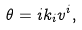Convert formula to latex. <formula><loc_0><loc_0><loc_500><loc_500>\theta = i k _ { i } v ^ { i } ,</formula> 